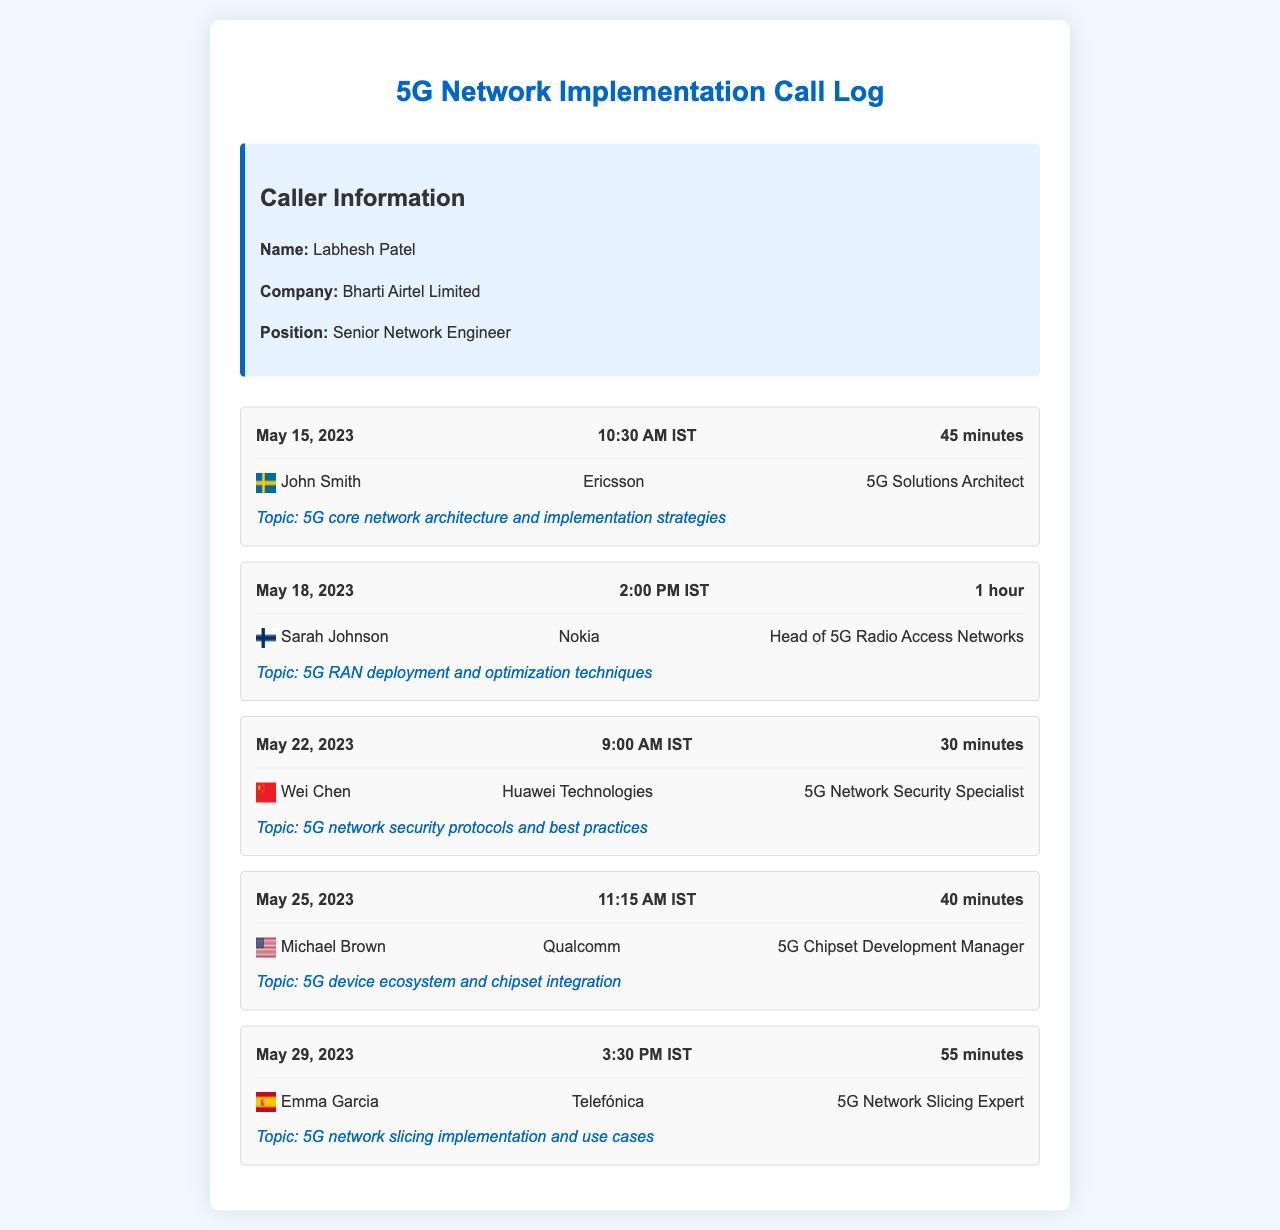What is the date of the call with John Smith? The date of the call with John Smith is mentioned in the document as May 15, 2023.
Answer: May 15, 2023 Who is the Head of 5G Radio Access Networks? Sarah Johnson is identified as the Head of 5G Radio Access Networks in the call entry details.
Answer: Sarah Johnson How long was the call with Emma Garcia? The duration of the call with Emma Garcia is specified as 55 minutes.
Answer: 55 minutes Which company did Wei Chen represent? Wei Chen is associated with Huawei Technologies according to the document.
Answer: Huawei Technologies What is the main topic of the call on May 25, 2023? The main topic of the call on May 25, 2023 is referred to as 5G device ecosystem and chipset integration.
Answer: 5G device ecosystem and chipset integration Which country is represented by the flag of John Smith? The flag with John Smith represents Sweden as identified in the call details.
Answer: Sweden How many calls were made regarding 5G implementation strategies? The document contains a total of five calls made regarding 5G implementation strategies.
Answer: Five What is Labhesh Patel's position? Labhesh Patel's position is stated as Senior Network Engineer in the caller information section.
Answer: Senior Network Engineer Which date has a call with Michael Brown from Qualcomm? The date of the call with Michael Brown is listed as May 25, 2023 in the call log.
Answer: May 25, 2023 